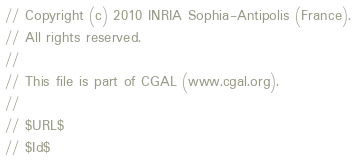Convert code to text. <code><loc_0><loc_0><loc_500><loc_500><_C++_>// Copyright (c) 2010 INRIA Sophia-Antipolis (France).
// All rights reserved.
//
// This file is part of CGAL (www.cgal.org).
//
// $URL$
// $Id$</code> 